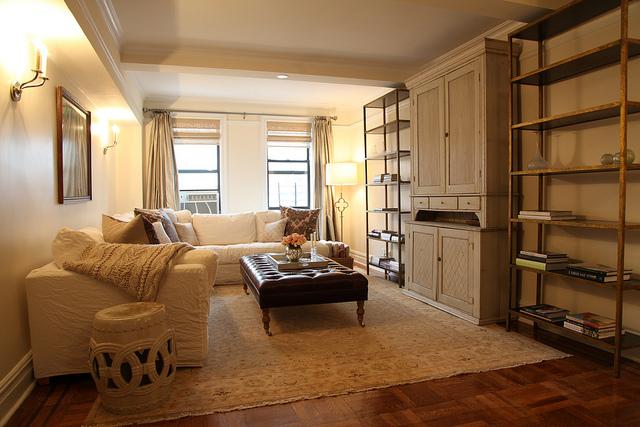Who is in the room?
Answer briefly. No one. Is this a family room?
Concise answer only. Yes. How many shelves are visible?
Be succinct. 14. 